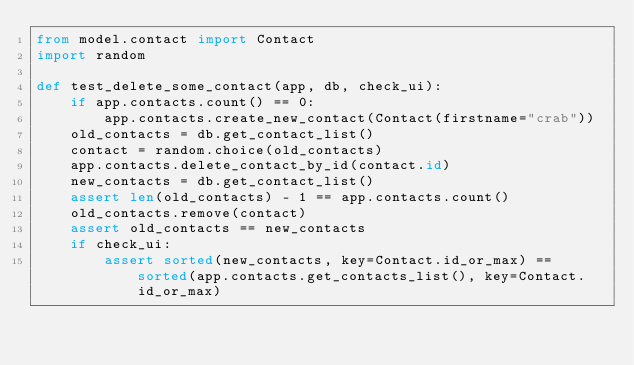<code> <loc_0><loc_0><loc_500><loc_500><_Python_>from model.contact import Contact
import random

def test_delete_some_contact(app, db, check_ui):
    if app.contacts.count() == 0:
        app.contacts.create_new_contact(Contact(firstname="crab"))
    old_contacts = db.get_contact_list()
    contact = random.choice(old_contacts)
    app.contacts.delete_contact_by_id(contact.id)
    new_contacts = db.get_contact_list()
    assert len(old_contacts) - 1 == app.contacts.count()
    old_contacts.remove(contact)
    assert old_contacts == new_contacts
    if check_ui:
        assert sorted(new_contacts, key=Contact.id_or_max) == sorted(app.contacts.get_contacts_list(), key=Contact.id_or_max)


</code> 